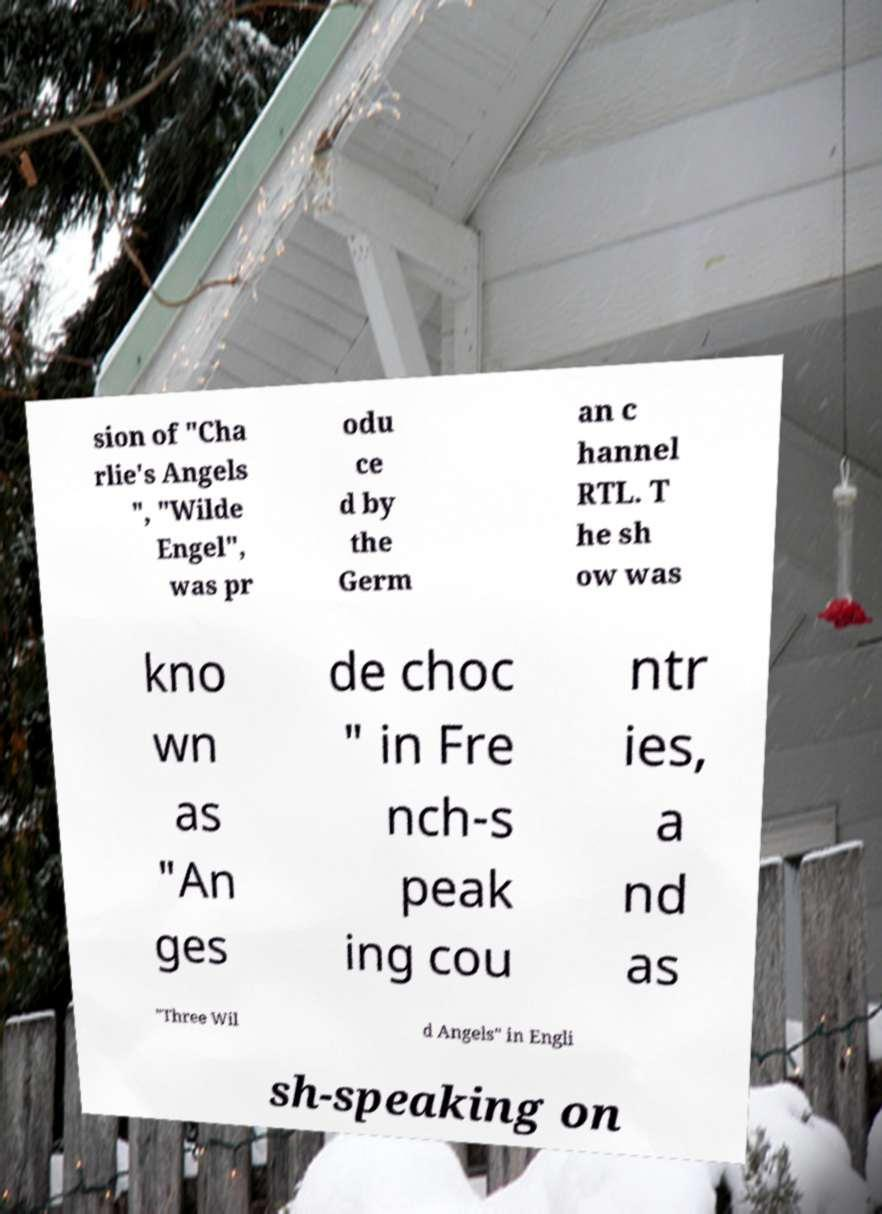Could you assist in decoding the text presented in this image and type it out clearly? sion of "Cha rlie's Angels ", "Wilde Engel", was pr odu ce d by the Germ an c hannel RTL. T he sh ow was kno wn as "An ges de choc " in Fre nch-s peak ing cou ntr ies, a nd as "Three Wil d Angels" in Engli sh-speaking on 